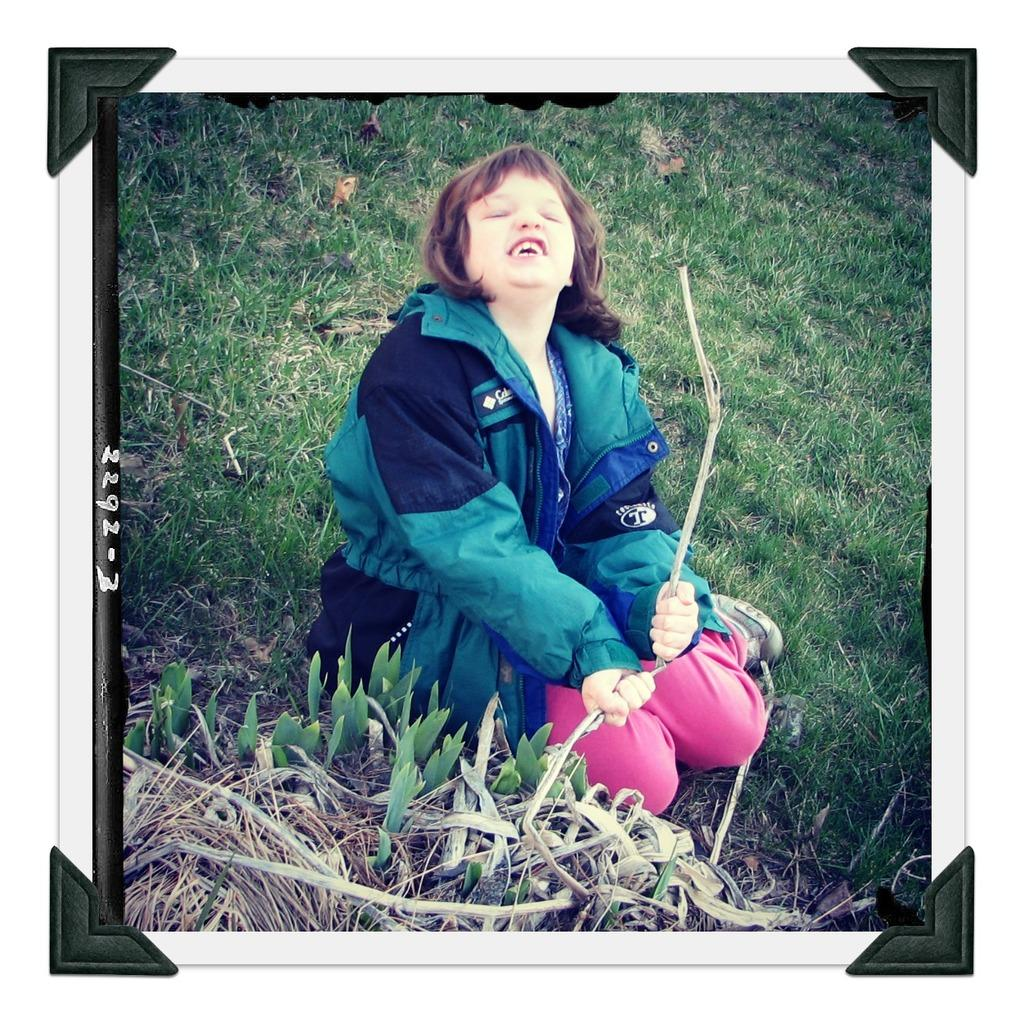Who is the main subject in the image? There is a girl in the image. What is the girl doing in the image? The girl is sitting on the ground. What is the girl holding in the image? The girl is holding a branch of a tree. What type of natural environment is visible in the image? There is grass and plants visible in the image. What type of wire is being used to create a flame in the image? There is no wire or flame present in the image. The girl is simply holding a branch of a tree. 